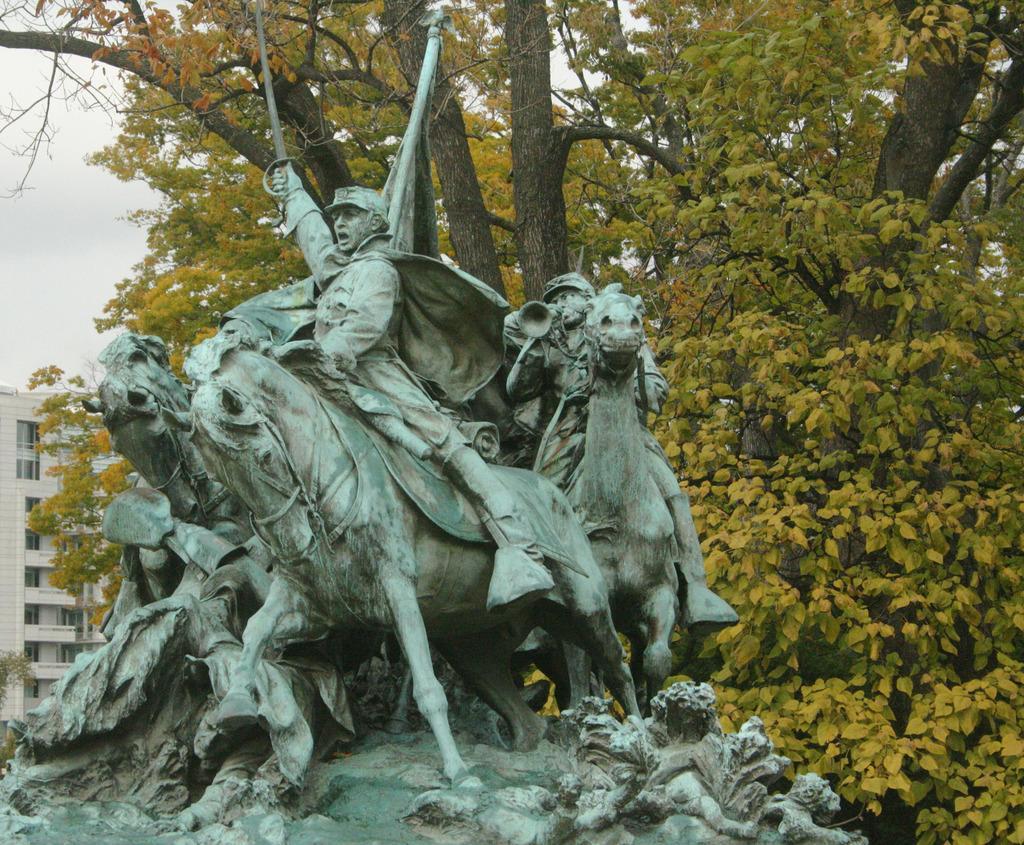In one or two sentences, can you explain what this image depicts? In this picture we can see a statue and in the background we can see a building, trees, sky. 